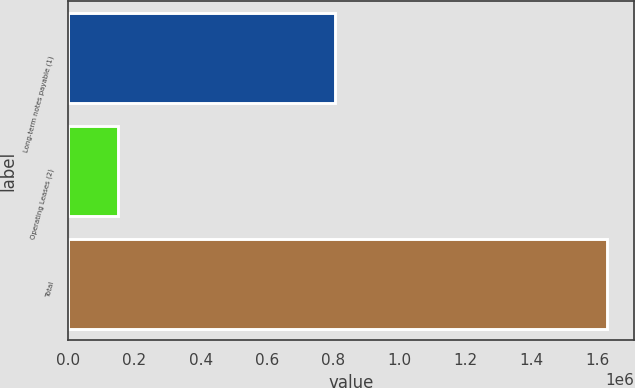<chart> <loc_0><loc_0><loc_500><loc_500><bar_chart><fcel>Long-term notes payable (1)<fcel>Operating Leases (2)<fcel>Total<nl><fcel>804940<fcel>149777<fcel>1.62926e+06<nl></chart> 